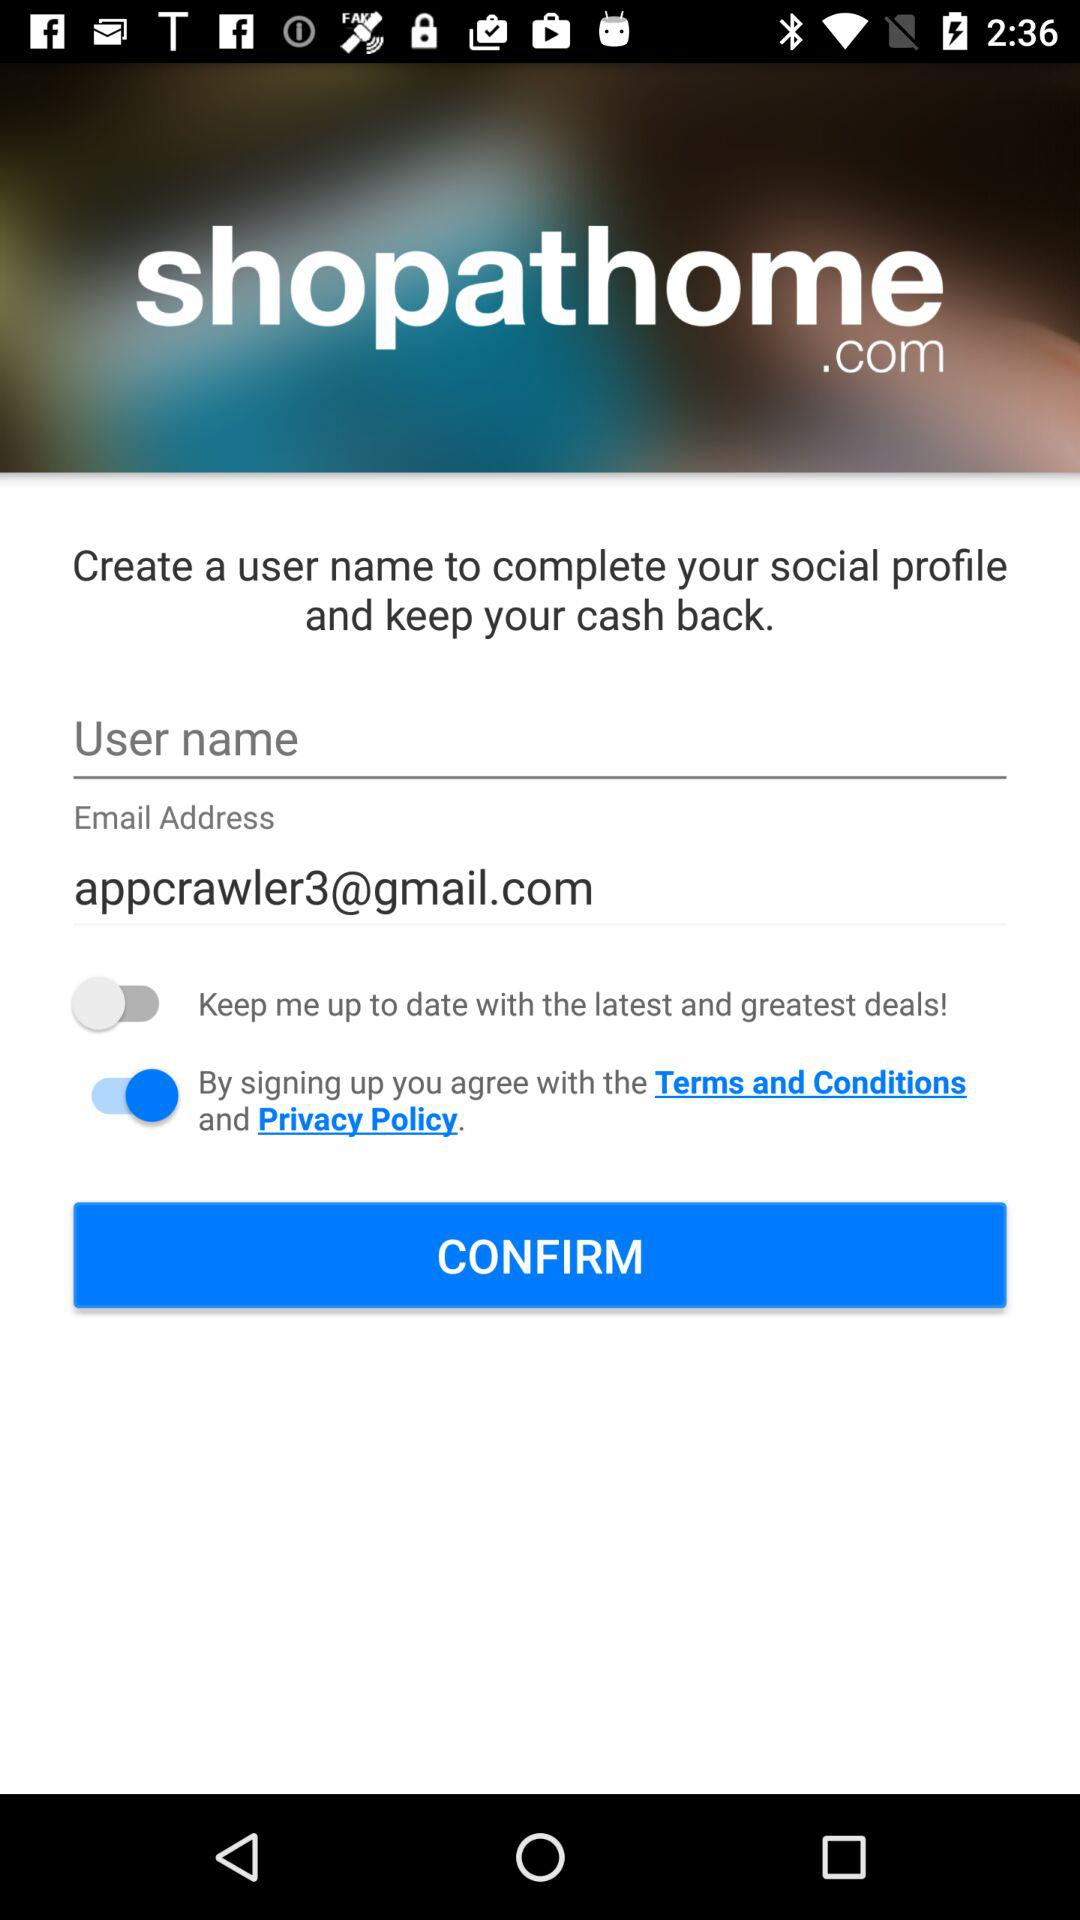How many text inputs have a value in them?
Answer the question using a single word or phrase. 1 